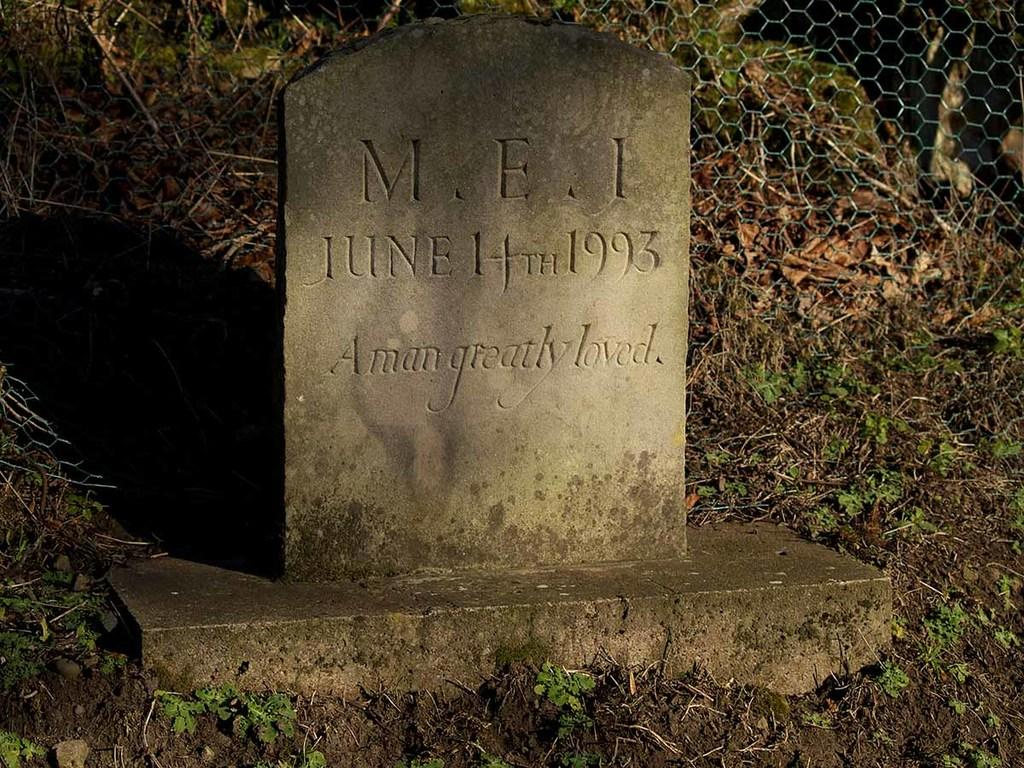What is the main object in the image? There is a headstone in the image. What can be observed around the headstone? The shadow of the headstone is visible, and there is soil and grass in the image. What is present in the background of the image? There is net fencing in the background of the image. What type of thunder can be heard in the image? There is no sound present in the image, so it is not possible to determine if any thunder can be heard. 